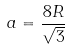<formula> <loc_0><loc_0><loc_500><loc_500>a = \frac { 8 R } { \sqrt { 3 } }</formula> 